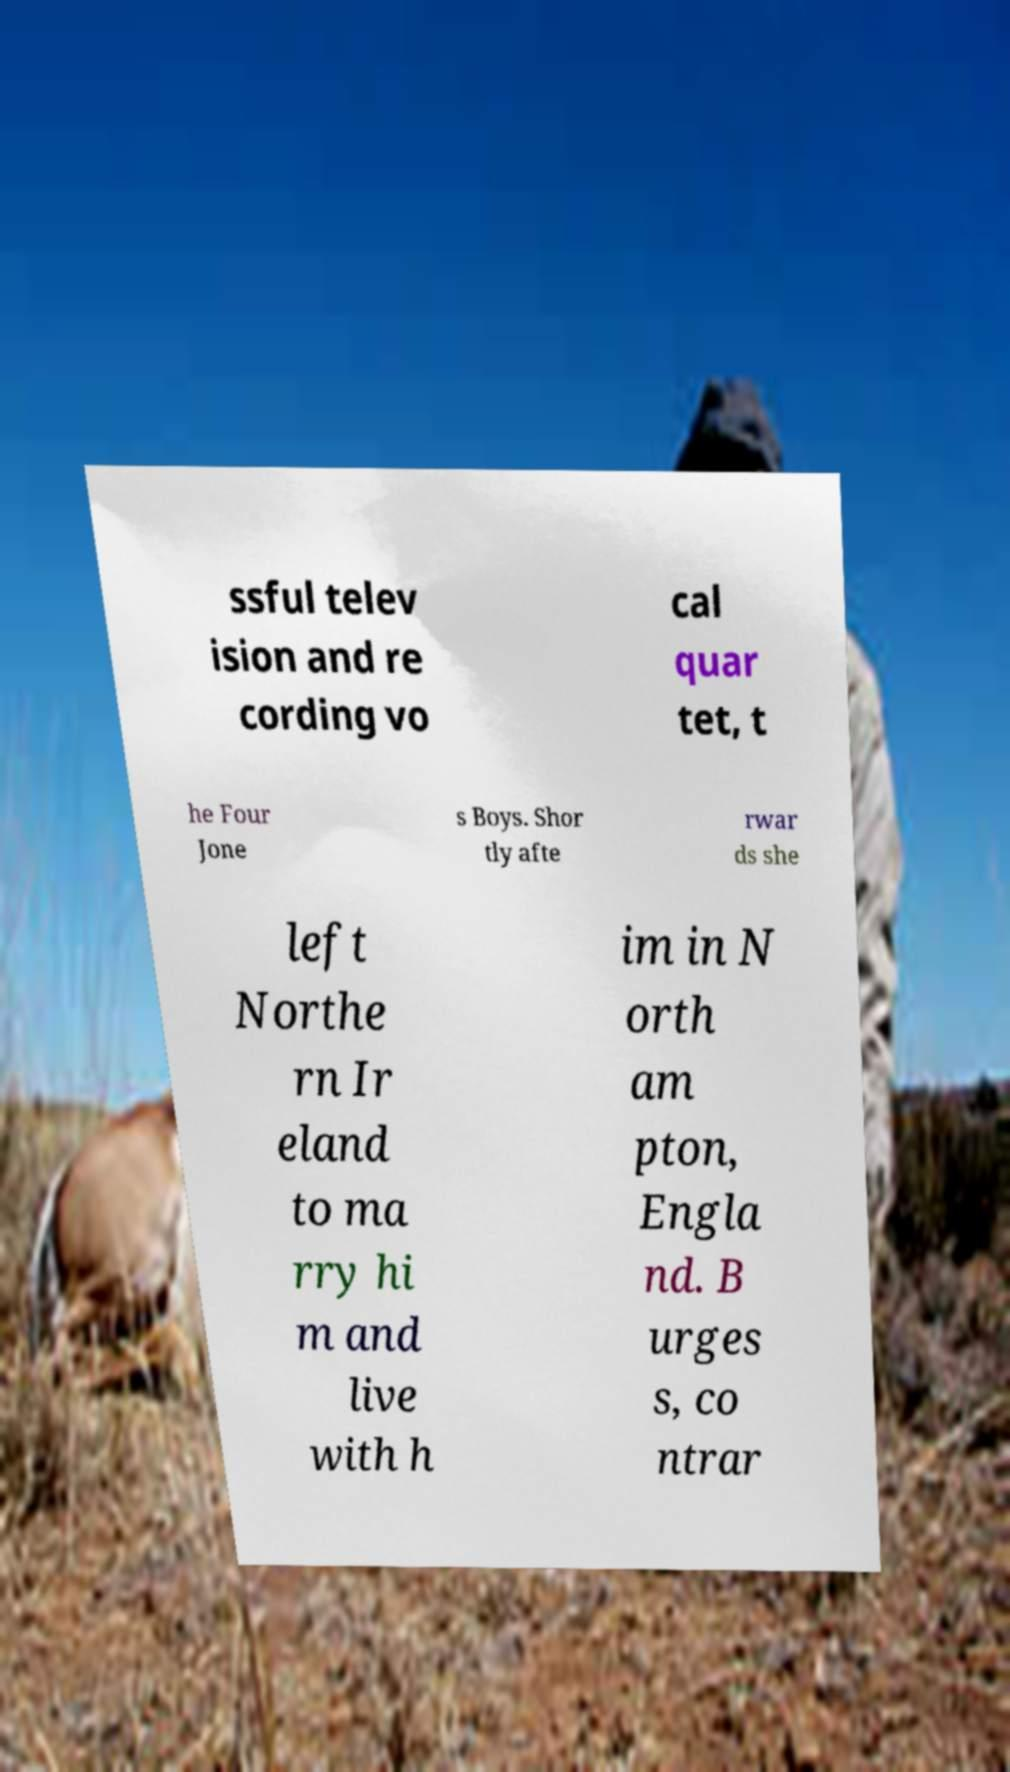For documentation purposes, I need the text within this image transcribed. Could you provide that? ssful telev ision and re cording vo cal quar tet, t he Four Jone s Boys. Shor tly afte rwar ds she left Northe rn Ir eland to ma rry hi m and live with h im in N orth am pton, Engla nd. B urges s, co ntrar 